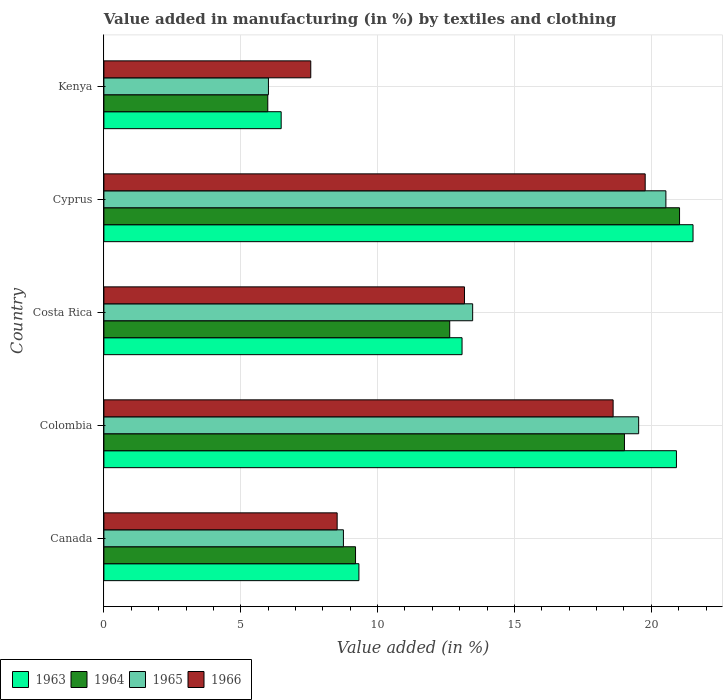How many bars are there on the 3rd tick from the top?
Offer a terse response. 4. What is the label of the 4th group of bars from the top?
Give a very brief answer. Colombia. In how many cases, is the number of bars for a given country not equal to the number of legend labels?
Keep it short and to the point. 0. What is the percentage of value added in manufacturing by textiles and clothing in 1965 in Cyprus?
Ensure brevity in your answer.  20.53. Across all countries, what is the maximum percentage of value added in manufacturing by textiles and clothing in 1966?
Offer a very short reply. 19.78. Across all countries, what is the minimum percentage of value added in manufacturing by textiles and clothing in 1966?
Give a very brief answer. 7.56. In which country was the percentage of value added in manufacturing by textiles and clothing in 1964 maximum?
Provide a succinct answer. Cyprus. In which country was the percentage of value added in manufacturing by textiles and clothing in 1965 minimum?
Keep it short and to the point. Kenya. What is the total percentage of value added in manufacturing by textiles and clothing in 1963 in the graph?
Ensure brevity in your answer.  71.32. What is the difference between the percentage of value added in manufacturing by textiles and clothing in 1964 in Colombia and that in Cyprus?
Ensure brevity in your answer.  -2.01. What is the difference between the percentage of value added in manufacturing by textiles and clothing in 1964 in Kenya and the percentage of value added in manufacturing by textiles and clothing in 1965 in Cyprus?
Your response must be concise. -14.54. What is the average percentage of value added in manufacturing by textiles and clothing in 1963 per country?
Ensure brevity in your answer.  14.26. What is the difference between the percentage of value added in manufacturing by textiles and clothing in 1964 and percentage of value added in manufacturing by textiles and clothing in 1966 in Kenya?
Your answer should be very brief. -1.57. In how many countries, is the percentage of value added in manufacturing by textiles and clothing in 1966 greater than 2 %?
Ensure brevity in your answer.  5. What is the ratio of the percentage of value added in manufacturing by textiles and clothing in 1964 in Cyprus to that in Kenya?
Ensure brevity in your answer.  3.51. Is the percentage of value added in manufacturing by textiles and clothing in 1963 in Canada less than that in Colombia?
Your response must be concise. Yes. What is the difference between the highest and the second highest percentage of value added in manufacturing by textiles and clothing in 1963?
Keep it short and to the point. 0.61. What is the difference between the highest and the lowest percentage of value added in manufacturing by textiles and clothing in 1965?
Your answer should be compact. 14.52. Is it the case that in every country, the sum of the percentage of value added in manufacturing by textiles and clothing in 1964 and percentage of value added in manufacturing by textiles and clothing in 1966 is greater than the sum of percentage of value added in manufacturing by textiles and clothing in 1965 and percentage of value added in manufacturing by textiles and clothing in 1963?
Your answer should be very brief. No. What does the 2nd bar from the top in Colombia represents?
Give a very brief answer. 1965. What does the 4th bar from the bottom in Canada represents?
Offer a very short reply. 1966. Is it the case that in every country, the sum of the percentage of value added in manufacturing by textiles and clothing in 1965 and percentage of value added in manufacturing by textiles and clothing in 1964 is greater than the percentage of value added in manufacturing by textiles and clothing in 1963?
Ensure brevity in your answer.  Yes. What is the difference between two consecutive major ticks on the X-axis?
Your response must be concise. 5. Are the values on the major ticks of X-axis written in scientific E-notation?
Your answer should be compact. No. Does the graph contain any zero values?
Offer a terse response. No. Where does the legend appear in the graph?
Offer a terse response. Bottom left. How many legend labels are there?
Make the answer very short. 4. What is the title of the graph?
Keep it short and to the point. Value added in manufacturing (in %) by textiles and clothing. What is the label or title of the X-axis?
Ensure brevity in your answer.  Value added (in %). What is the Value added (in %) of 1963 in Canada?
Your answer should be very brief. 9.32. What is the Value added (in %) of 1964 in Canada?
Keep it short and to the point. 9.19. What is the Value added (in %) in 1965 in Canada?
Offer a very short reply. 8.75. What is the Value added (in %) in 1966 in Canada?
Keep it short and to the point. 8.52. What is the Value added (in %) of 1963 in Colombia?
Give a very brief answer. 20.92. What is the Value added (in %) in 1964 in Colombia?
Give a very brief answer. 19.02. What is the Value added (in %) of 1965 in Colombia?
Keep it short and to the point. 19.54. What is the Value added (in %) of 1966 in Colombia?
Your answer should be compact. 18.6. What is the Value added (in %) of 1963 in Costa Rica?
Give a very brief answer. 13.08. What is the Value added (in %) of 1964 in Costa Rica?
Your answer should be compact. 12.63. What is the Value added (in %) in 1965 in Costa Rica?
Your response must be concise. 13.47. What is the Value added (in %) of 1966 in Costa Rica?
Provide a succinct answer. 13.17. What is the Value added (in %) of 1963 in Cyprus?
Make the answer very short. 21.52. What is the Value added (in %) of 1964 in Cyprus?
Your answer should be compact. 21.03. What is the Value added (in %) in 1965 in Cyprus?
Offer a very short reply. 20.53. What is the Value added (in %) in 1966 in Cyprus?
Keep it short and to the point. 19.78. What is the Value added (in %) in 1963 in Kenya?
Your response must be concise. 6.48. What is the Value added (in %) of 1964 in Kenya?
Give a very brief answer. 5.99. What is the Value added (in %) in 1965 in Kenya?
Offer a very short reply. 6.01. What is the Value added (in %) of 1966 in Kenya?
Offer a terse response. 7.56. Across all countries, what is the maximum Value added (in %) of 1963?
Provide a short and direct response. 21.52. Across all countries, what is the maximum Value added (in %) in 1964?
Ensure brevity in your answer.  21.03. Across all countries, what is the maximum Value added (in %) in 1965?
Make the answer very short. 20.53. Across all countries, what is the maximum Value added (in %) of 1966?
Provide a succinct answer. 19.78. Across all countries, what is the minimum Value added (in %) in 1963?
Your answer should be very brief. 6.48. Across all countries, what is the minimum Value added (in %) in 1964?
Make the answer very short. 5.99. Across all countries, what is the minimum Value added (in %) in 1965?
Provide a succinct answer. 6.01. Across all countries, what is the minimum Value added (in %) of 1966?
Give a very brief answer. 7.56. What is the total Value added (in %) in 1963 in the graph?
Provide a succinct answer. 71.32. What is the total Value added (in %) in 1964 in the graph?
Provide a short and direct response. 67.86. What is the total Value added (in %) of 1965 in the graph?
Make the answer very short. 68.3. What is the total Value added (in %) in 1966 in the graph?
Offer a terse response. 67.63. What is the difference between the Value added (in %) of 1963 in Canada and that in Colombia?
Keep it short and to the point. -11.6. What is the difference between the Value added (in %) of 1964 in Canada and that in Colombia?
Make the answer very short. -9.82. What is the difference between the Value added (in %) of 1965 in Canada and that in Colombia?
Offer a terse response. -10.79. What is the difference between the Value added (in %) in 1966 in Canada and that in Colombia?
Your answer should be compact. -10.08. What is the difference between the Value added (in %) of 1963 in Canada and that in Costa Rica?
Offer a terse response. -3.77. What is the difference between the Value added (in %) of 1964 in Canada and that in Costa Rica?
Make the answer very short. -3.44. What is the difference between the Value added (in %) of 1965 in Canada and that in Costa Rica?
Ensure brevity in your answer.  -4.72. What is the difference between the Value added (in %) of 1966 in Canada and that in Costa Rica?
Make the answer very short. -4.65. What is the difference between the Value added (in %) in 1963 in Canada and that in Cyprus?
Your answer should be very brief. -12.21. What is the difference between the Value added (in %) of 1964 in Canada and that in Cyprus?
Provide a succinct answer. -11.84. What is the difference between the Value added (in %) of 1965 in Canada and that in Cyprus?
Your answer should be very brief. -11.78. What is the difference between the Value added (in %) of 1966 in Canada and that in Cyprus?
Provide a short and direct response. -11.25. What is the difference between the Value added (in %) of 1963 in Canada and that in Kenya?
Give a very brief answer. 2.84. What is the difference between the Value added (in %) of 1964 in Canada and that in Kenya?
Your response must be concise. 3.21. What is the difference between the Value added (in %) in 1965 in Canada and that in Kenya?
Provide a short and direct response. 2.74. What is the difference between the Value added (in %) of 1966 in Canada and that in Kenya?
Keep it short and to the point. 0.96. What is the difference between the Value added (in %) of 1963 in Colombia and that in Costa Rica?
Ensure brevity in your answer.  7.83. What is the difference between the Value added (in %) in 1964 in Colombia and that in Costa Rica?
Offer a terse response. 6.38. What is the difference between the Value added (in %) of 1965 in Colombia and that in Costa Rica?
Your answer should be compact. 6.06. What is the difference between the Value added (in %) of 1966 in Colombia and that in Costa Rica?
Make the answer very short. 5.43. What is the difference between the Value added (in %) of 1963 in Colombia and that in Cyprus?
Ensure brevity in your answer.  -0.61. What is the difference between the Value added (in %) in 1964 in Colombia and that in Cyprus?
Offer a terse response. -2.01. What is the difference between the Value added (in %) of 1965 in Colombia and that in Cyprus?
Make the answer very short. -0.99. What is the difference between the Value added (in %) of 1966 in Colombia and that in Cyprus?
Offer a very short reply. -1.17. What is the difference between the Value added (in %) of 1963 in Colombia and that in Kenya?
Give a very brief answer. 14.44. What is the difference between the Value added (in %) in 1964 in Colombia and that in Kenya?
Provide a succinct answer. 13.03. What is the difference between the Value added (in %) of 1965 in Colombia and that in Kenya?
Offer a terse response. 13.53. What is the difference between the Value added (in %) in 1966 in Colombia and that in Kenya?
Your answer should be very brief. 11.05. What is the difference between the Value added (in %) in 1963 in Costa Rica and that in Cyprus?
Your answer should be very brief. -8.44. What is the difference between the Value added (in %) of 1964 in Costa Rica and that in Cyprus?
Make the answer very short. -8.4. What is the difference between the Value added (in %) in 1965 in Costa Rica and that in Cyprus?
Provide a succinct answer. -7.06. What is the difference between the Value added (in %) of 1966 in Costa Rica and that in Cyprus?
Ensure brevity in your answer.  -6.6. What is the difference between the Value added (in %) in 1963 in Costa Rica and that in Kenya?
Provide a succinct answer. 6.61. What is the difference between the Value added (in %) in 1964 in Costa Rica and that in Kenya?
Provide a succinct answer. 6.65. What is the difference between the Value added (in %) of 1965 in Costa Rica and that in Kenya?
Offer a very short reply. 7.46. What is the difference between the Value added (in %) in 1966 in Costa Rica and that in Kenya?
Provide a succinct answer. 5.62. What is the difference between the Value added (in %) of 1963 in Cyprus and that in Kenya?
Ensure brevity in your answer.  15.05. What is the difference between the Value added (in %) of 1964 in Cyprus and that in Kenya?
Keep it short and to the point. 15.04. What is the difference between the Value added (in %) in 1965 in Cyprus and that in Kenya?
Your answer should be compact. 14.52. What is the difference between the Value added (in %) in 1966 in Cyprus and that in Kenya?
Keep it short and to the point. 12.22. What is the difference between the Value added (in %) in 1963 in Canada and the Value added (in %) in 1964 in Colombia?
Offer a terse response. -9.7. What is the difference between the Value added (in %) in 1963 in Canada and the Value added (in %) in 1965 in Colombia?
Offer a very short reply. -10.22. What is the difference between the Value added (in %) of 1963 in Canada and the Value added (in %) of 1966 in Colombia?
Your answer should be very brief. -9.29. What is the difference between the Value added (in %) in 1964 in Canada and the Value added (in %) in 1965 in Colombia?
Your answer should be very brief. -10.34. What is the difference between the Value added (in %) in 1964 in Canada and the Value added (in %) in 1966 in Colombia?
Keep it short and to the point. -9.41. What is the difference between the Value added (in %) in 1965 in Canada and the Value added (in %) in 1966 in Colombia?
Your response must be concise. -9.85. What is the difference between the Value added (in %) in 1963 in Canada and the Value added (in %) in 1964 in Costa Rica?
Offer a very short reply. -3.32. What is the difference between the Value added (in %) of 1963 in Canada and the Value added (in %) of 1965 in Costa Rica?
Your response must be concise. -4.16. What is the difference between the Value added (in %) of 1963 in Canada and the Value added (in %) of 1966 in Costa Rica?
Your response must be concise. -3.86. What is the difference between the Value added (in %) of 1964 in Canada and the Value added (in %) of 1965 in Costa Rica?
Your response must be concise. -4.28. What is the difference between the Value added (in %) in 1964 in Canada and the Value added (in %) in 1966 in Costa Rica?
Offer a terse response. -3.98. What is the difference between the Value added (in %) in 1965 in Canada and the Value added (in %) in 1966 in Costa Rica?
Your response must be concise. -4.42. What is the difference between the Value added (in %) of 1963 in Canada and the Value added (in %) of 1964 in Cyprus?
Provide a succinct answer. -11.71. What is the difference between the Value added (in %) of 1963 in Canada and the Value added (in %) of 1965 in Cyprus?
Give a very brief answer. -11.21. What is the difference between the Value added (in %) in 1963 in Canada and the Value added (in %) in 1966 in Cyprus?
Your answer should be compact. -10.46. What is the difference between the Value added (in %) of 1964 in Canada and the Value added (in %) of 1965 in Cyprus?
Provide a short and direct response. -11.34. What is the difference between the Value added (in %) of 1964 in Canada and the Value added (in %) of 1966 in Cyprus?
Keep it short and to the point. -10.58. What is the difference between the Value added (in %) of 1965 in Canada and the Value added (in %) of 1966 in Cyprus?
Your answer should be very brief. -11.02. What is the difference between the Value added (in %) in 1963 in Canada and the Value added (in %) in 1964 in Kenya?
Offer a very short reply. 3.33. What is the difference between the Value added (in %) of 1963 in Canada and the Value added (in %) of 1965 in Kenya?
Provide a succinct answer. 3.31. What is the difference between the Value added (in %) of 1963 in Canada and the Value added (in %) of 1966 in Kenya?
Offer a terse response. 1.76. What is the difference between the Value added (in %) in 1964 in Canada and the Value added (in %) in 1965 in Kenya?
Provide a succinct answer. 3.18. What is the difference between the Value added (in %) in 1964 in Canada and the Value added (in %) in 1966 in Kenya?
Ensure brevity in your answer.  1.64. What is the difference between the Value added (in %) of 1965 in Canada and the Value added (in %) of 1966 in Kenya?
Make the answer very short. 1.19. What is the difference between the Value added (in %) in 1963 in Colombia and the Value added (in %) in 1964 in Costa Rica?
Offer a terse response. 8.28. What is the difference between the Value added (in %) of 1963 in Colombia and the Value added (in %) of 1965 in Costa Rica?
Offer a very short reply. 7.44. What is the difference between the Value added (in %) of 1963 in Colombia and the Value added (in %) of 1966 in Costa Rica?
Your answer should be compact. 7.74. What is the difference between the Value added (in %) in 1964 in Colombia and the Value added (in %) in 1965 in Costa Rica?
Your response must be concise. 5.55. What is the difference between the Value added (in %) of 1964 in Colombia and the Value added (in %) of 1966 in Costa Rica?
Offer a terse response. 5.84. What is the difference between the Value added (in %) of 1965 in Colombia and the Value added (in %) of 1966 in Costa Rica?
Your response must be concise. 6.36. What is the difference between the Value added (in %) in 1963 in Colombia and the Value added (in %) in 1964 in Cyprus?
Provide a short and direct response. -0.11. What is the difference between the Value added (in %) in 1963 in Colombia and the Value added (in %) in 1965 in Cyprus?
Provide a succinct answer. 0.39. What is the difference between the Value added (in %) of 1963 in Colombia and the Value added (in %) of 1966 in Cyprus?
Make the answer very short. 1.14. What is the difference between the Value added (in %) in 1964 in Colombia and the Value added (in %) in 1965 in Cyprus?
Ensure brevity in your answer.  -1.51. What is the difference between the Value added (in %) of 1964 in Colombia and the Value added (in %) of 1966 in Cyprus?
Your answer should be compact. -0.76. What is the difference between the Value added (in %) in 1965 in Colombia and the Value added (in %) in 1966 in Cyprus?
Make the answer very short. -0.24. What is the difference between the Value added (in %) of 1963 in Colombia and the Value added (in %) of 1964 in Kenya?
Your response must be concise. 14.93. What is the difference between the Value added (in %) in 1963 in Colombia and the Value added (in %) in 1965 in Kenya?
Give a very brief answer. 14.91. What is the difference between the Value added (in %) of 1963 in Colombia and the Value added (in %) of 1966 in Kenya?
Provide a short and direct response. 13.36. What is the difference between the Value added (in %) in 1964 in Colombia and the Value added (in %) in 1965 in Kenya?
Ensure brevity in your answer.  13.01. What is the difference between the Value added (in %) in 1964 in Colombia and the Value added (in %) in 1966 in Kenya?
Offer a terse response. 11.46. What is the difference between the Value added (in %) in 1965 in Colombia and the Value added (in %) in 1966 in Kenya?
Give a very brief answer. 11.98. What is the difference between the Value added (in %) of 1963 in Costa Rica and the Value added (in %) of 1964 in Cyprus?
Your response must be concise. -7.95. What is the difference between the Value added (in %) in 1963 in Costa Rica and the Value added (in %) in 1965 in Cyprus?
Offer a very short reply. -7.45. What is the difference between the Value added (in %) of 1963 in Costa Rica and the Value added (in %) of 1966 in Cyprus?
Keep it short and to the point. -6.69. What is the difference between the Value added (in %) in 1964 in Costa Rica and the Value added (in %) in 1965 in Cyprus?
Provide a short and direct response. -7.9. What is the difference between the Value added (in %) of 1964 in Costa Rica and the Value added (in %) of 1966 in Cyprus?
Your answer should be compact. -7.14. What is the difference between the Value added (in %) in 1965 in Costa Rica and the Value added (in %) in 1966 in Cyprus?
Your response must be concise. -6.3. What is the difference between the Value added (in %) in 1963 in Costa Rica and the Value added (in %) in 1964 in Kenya?
Give a very brief answer. 7.1. What is the difference between the Value added (in %) in 1963 in Costa Rica and the Value added (in %) in 1965 in Kenya?
Offer a very short reply. 7.07. What is the difference between the Value added (in %) in 1963 in Costa Rica and the Value added (in %) in 1966 in Kenya?
Give a very brief answer. 5.53. What is the difference between the Value added (in %) in 1964 in Costa Rica and the Value added (in %) in 1965 in Kenya?
Give a very brief answer. 6.62. What is the difference between the Value added (in %) in 1964 in Costa Rica and the Value added (in %) in 1966 in Kenya?
Provide a short and direct response. 5.08. What is the difference between the Value added (in %) in 1965 in Costa Rica and the Value added (in %) in 1966 in Kenya?
Your answer should be very brief. 5.91. What is the difference between the Value added (in %) of 1963 in Cyprus and the Value added (in %) of 1964 in Kenya?
Ensure brevity in your answer.  15.54. What is the difference between the Value added (in %) in 1963 in Cyprus and the Value added (in %) in 1965 in Kenya?
Provide a succinct answer. 15.51. What is the difference between the Value added (in %) in 1963 in Cyprus and the Value added (in %) in 1966 in Kenya?
Provide a succinct answer. 13.97. What is the difference between the Value added (in %) in 1964 in Cyprus and the Value added (in %) in 1965 in Kenya?
Offer a very short reply. 15.02. What is the difference between the Value added (in %) in 1964 in Cyprus and the Value added (in %) in 1966 in Kenya?
Keep it short and to the point. 13.47. What is the difference between the Value added (in %) of 1965 in Cyprus and the Value added (in %) of 1966 in Kenya?
Make the answer very short. 12.97. What is the average Value added (in %) of 1963 per country?
Your answer should be very brief. 14.26. What is the average Value added (in %) of 1964 per country?
Offer a terse response. 13.57. What is the average Value added (in %) of 1965 per country?
Provide a short and direct response. 13.66. What is the average Value added (in %) of 1966 per country?
Offer a terse response. 13.53. What is the difference between the Value added (in %) in 1963 and Value added (in %) in 1964 in Canada?
Offer a very short reply. 0.12. What is the difference between the Value added (in %) in 1963 and Value added (in %) in 1965 in Canada?
Offer a terse response. 0.57. What is the difference between the Value added (in %) in 1963 and Value added (in %) in 1966 in Canada?
Your answer should be compact. 0.8. What is the difference between the Value added (in %) of 1964 and Value added (in %) of 1965 in Canada?
Your response must be concise. 0.44. What is the difference between the Value added (in %) in 1964 and Value added (in %) in 1966 in Canada?
Ensure brevity in your answer.  0.67. What is the difference between the Value added (in %) of 1965 and Value added (in %) of 1966 in Canada?
Keep it short and to the point. 0.23. What is the difference between the Value added (in %) of 1963 and Value added (in %) of 1964 in Colombia?
Your answer should be very brief. 1.9. What is the difference between the Value added (in %) of 1963 and Value added (in %) of 1965 in Colombia?
Your answer should be compact. 1.38. What is the difference between the Value added (in %) of 1963 and Value added (in %) of 1966 in Colombia?
Make the answer very short. 2.31. What is the difference between the Value added (in %) in 1964 and Value added (in %) in 1965 in Colombia?
Your answer should be very brief. -0.52. What is the difference between the Value added (in %) in 1964 and Value added (in %) in 1966 in Colombia?
Provide a short and direct response. 0.41. What is the difference between the Value added (in %) in 1965 and Value added (in %) in 1966 in Colombia?
Your response must be concise. 0.93. What is the difference between the Value added (in %) of 1963 and Value added (in %) of 1964 in Costa Rica?
Offer a very short reply. 0.45. What is the difference between the Value added (in %) of 1963 and Value added (in %) of 1965 in Costa Rica?
Ensure brevity in your answer.  -0.39. What is the difference between the Value added (in %) of 1963 and Value added (in %) of 1966 in Costa Rica?
Provide a succinct answer. -0.09. What is the difference between the Value added (in %) in 1964 and Value added (in %) in 1965 in Costa Rica?
Your answer should be very brief. -0.84. What is the difference between the Value added (in %) in 1964 and Value added (in %) in 1966 in Costa Rica?
Make the answer very short. -0.54. What is the difference between the Value added (in %) in 1965 and Value added (in %) in 1966 in Costa Rica?
Offer a very short reply. 0.3. What is the difference between the Value added (in %) in 1963 and Value added (in %) in 1964 in Cyprus?
Your answer should be very brief. 0.49. What is the difference between the Value added (in %) in 1963 and Value added (in %) in 1966 in Cyprus?
Offer a terse response. 1.75. What is the difference between the Value added (in %) of 1964 and Value added (in %) of 1965 in Cyprus?
Your answer should be compact. 0.5. What is the difference between the Value added (in %) of 1964 and Value added (in %) of 1966 in Cyprus?
Your answer should be compact. 1.25. What is the difference between the Value added (in %) of 1965 and Value added (in %) of 1966 in Cyprus?
Your response must be concise. 0.76. What is the difference between the Value added (in %) in 1963 and Value added (in %) in 1964 in Kenya?
Make the answer very short. 0.49. What is the difference between the Value added (in %) in 1963 and Value added (in %) in 1965 in Kenya?
Your response must be concise. 0.47. What is the difference between the Value added (in %) in 1963 and Value added (in %) in 1966 in Kenya?
Provide a succinct answer. -1.08. What is the difference between the Value added (in %) of 1964 and Value added (in %) of 1965 in Kenya?
Your answer should be very brief. -0.02. What is the difference between the Value added (in %) in 1964 and Value added (in %) in 1966 in Kenya?
Offer a very short reply. -1.57. What is the difference between the Value added (in %) of 1965 and Value added (in %) of 1966 in Kenya?
Your answer should be very brief. -1.55. What is the ratio of the Value added (in %) in 1963 in Canada to that in Colombia?
Give a very brief answer. 0.45. What is the ratio of the Value added (in %) in 1964 in Canada to that in Colombia?
Offer a very short reply. 0.48. What is the ratio of the Value added (in %) in 1965 in Canada to that in Colombia?
Ensure brevity in your answer.  0.45. What is the ratio of the Value added (in %) in 1966 in Canada to that in Colombia?
Offer a terse response. 0.46. What is the ratio of the Value added (in %) of 1963 in Canada to that in Costa Rica?
Give a very brief answer. 0.71. What is the ratio of the Value added (in %) of 1964 in Canada to that in Costa Rica?
Keep it short and to the point. 0.73. What is the ratio of the Value added (in %) of 1965 in Canada to that in Costa Rica?
Give a very brief answer. 0.65. What is the ratio of the Value added (in %) of 1966 in Canada to that in Costa Rica?
Ensure brevity in your answer.  0.65. What is the ratio of the Value added (in %) of 1963 in Canada to that in Cyprus?
Provide a short and direct response. 0.43. What is the ratio of the Value added (in %) of 1964 in Canada to that in Cyprus?
Your answer should be very brief. 0.44. What is the ratio of the Value added (in %) of 1965 in Canada to that in Cyprus?
Provide a short and direct response. 0.43. What is the ratio of the Value added (in %) in 1966 in Canada to that in Cyprus?
Offer a terse response. 0.43. What is the ratio of the Value added (in %) in 1963 in Canada to that in Kenya?
Ensure brevity in your answer.  1.44. What is the ratio of the Value added (in %) of 1964 in Canada to that in Kenya?
Make the answer very short. 1.54. What is the ratio of the Value added (in %) in 1965 in Canada to that in Kenya?
Give a very brief answer. 1.46. What is the ratio of the Value added (in %) in 1966 in Canada to that in Kenya?
Ensure brevity in your answer.  1.13. What is the ratio of the Value added (in %) in 1963 in Colombia to that in Costa Rica?
Ensure brevity in your answer.  1.6. What is the ratio of the Value added (in %) in 1964 in Colombia to that in Costa Rica?
Offer a very short reply. 1.51. What is the ratio of the Value added (in %) in 1965 in Colombia to that in Costa Rica?
Keep it short and to the point. 1.45. What is the ratio of the Value added (in %) in 1966 in Colombia to that in Costa Rica?
Provide a short and direct response. 1.41. What is the ratio of the Value added (in %) of 1963 in Colombia to that in Cyprus?
Make the answer very short. 0.97. What is the ratio of the Value added (in %) of 1964 in Colombia to that in Cyprus?
Your answer should be compact. 0.9. What is the ratio of the Value added (in %) in 1965 in Colombia to that in Cyprus?
Provide a succinct answer. 0.95. What is the ratio of the Value added (in %) in 1966 in Colombia to that in Cyprus?
Ensure brevity in your answer.  0.94. What is the ratio of the Value added (in %) of 1963 in Colombia to that in Kenya?
Make the answer very short. 3.23. What is the ratio of the Value added (in %) of 1964 in Colombia to that in Kenya?
Offer a terse response. 3.18. What is the ratio of the Value added (in %) in 1966 in Colombia to that in Kenya?
Offer a terse response. 2.46. What is the ratio of the Value added (in %) in 1963 in Costa Rica to that in Cyprus?
Ensure brevity in your answer.  0.61. What is the ratio of the Value added (in %) in 1964 in Costa Rica to that in Cyprus?
Offer a very short reply. 0.6. What is the ratio of the Value added (in %) in 1965 in Costa Rica to that in Cyprus?
Offer a very short reply. 0.66. What is the ratio of the Value added (in %) in 1966 in Costa Rica to that in Cyprus?
Make the answer very short. 0.67. What is the ratio of the Value added (in %) in 1963 in Costa Rica to that in Kenya?
Keep it short and to the point. 2.02. What is the ratio of the Value added (in %) in 1964 in Costa Rica to that in Kenya?
Your answer should be compact. 2.11. What is the ratio of the Value added (in %) of 1965 in Costa Rica to that in Kenya?
Ensure brevity in your answer.  2.24. What is the ratio of the Value added (in %) of 1966 in Costa Rica to that in Kenya?
Ensure brevity in your answer.  1.74. What is the ratio of the Value added (in %) of 1963 in Cyprus to that in Kenya?
Make the answer very short. 3.32. What is the ratio of the Value added (in %) of 1964 in Cyprus to that in Kenya?
Provide a succinct answer. 3.51. What is the ratio of the Value added (in %) in 1965 in Cyprus to that in Kenya?
Ensure brevity in your answer.  3.42. What is the ratio of the Value added (in %) of 1966 in Cyprus to that in Kenya?
Give a very brief answer. 2.62. What is the difference between the highest and the second highest Value added (in %) in 1963?
Your response must be concise. 0.61. What is the difference between the highest and the second highest Value added (in %) of 1964?
Keep it short and to the point. 2.01. What is the difference between the highest and the second highest Value added (in %) of 1966?
Offer a very short reply. 1.17. What is the difference between the highest and the lowest Value added (in %) in 1963?
Keep it short and to the point. 15.05. What is the difference between the highest and the lowest Value added (in %) of 1964?
Your answer should be compact. 15.04. What is the difference between the highest and the lowest Value added (in %) in 1965?
Keep it short and to the point. 14.52. What is the difference between the highest and the lowest Value added (in %) in 1966?
Keep it short and to the point. 12.22. 